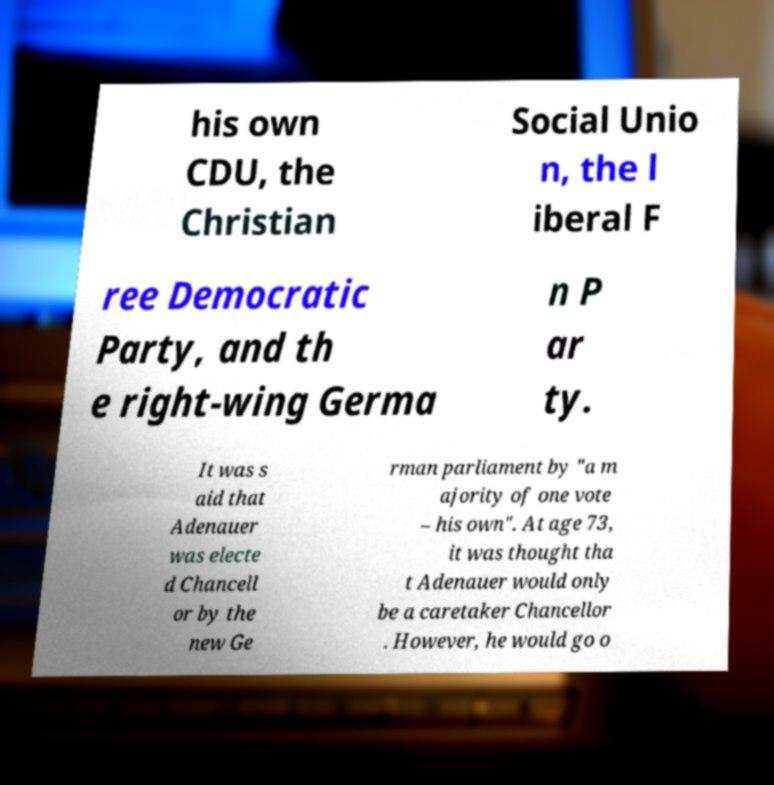Please read and relay the text visible in this image. What does it say? his own CDU, the Christian Social Unio n, the l iberal F ree Democratic Party, and th e right-wing Germa n P ar ty. It was s aid that Adenauer was electe d Chancell or by the new Ge rman parliament by "a m ajority of one vote – his own". At age 73, it was thought tha t Adenauer would only be a caretaker Chancellor . However, he would go o 